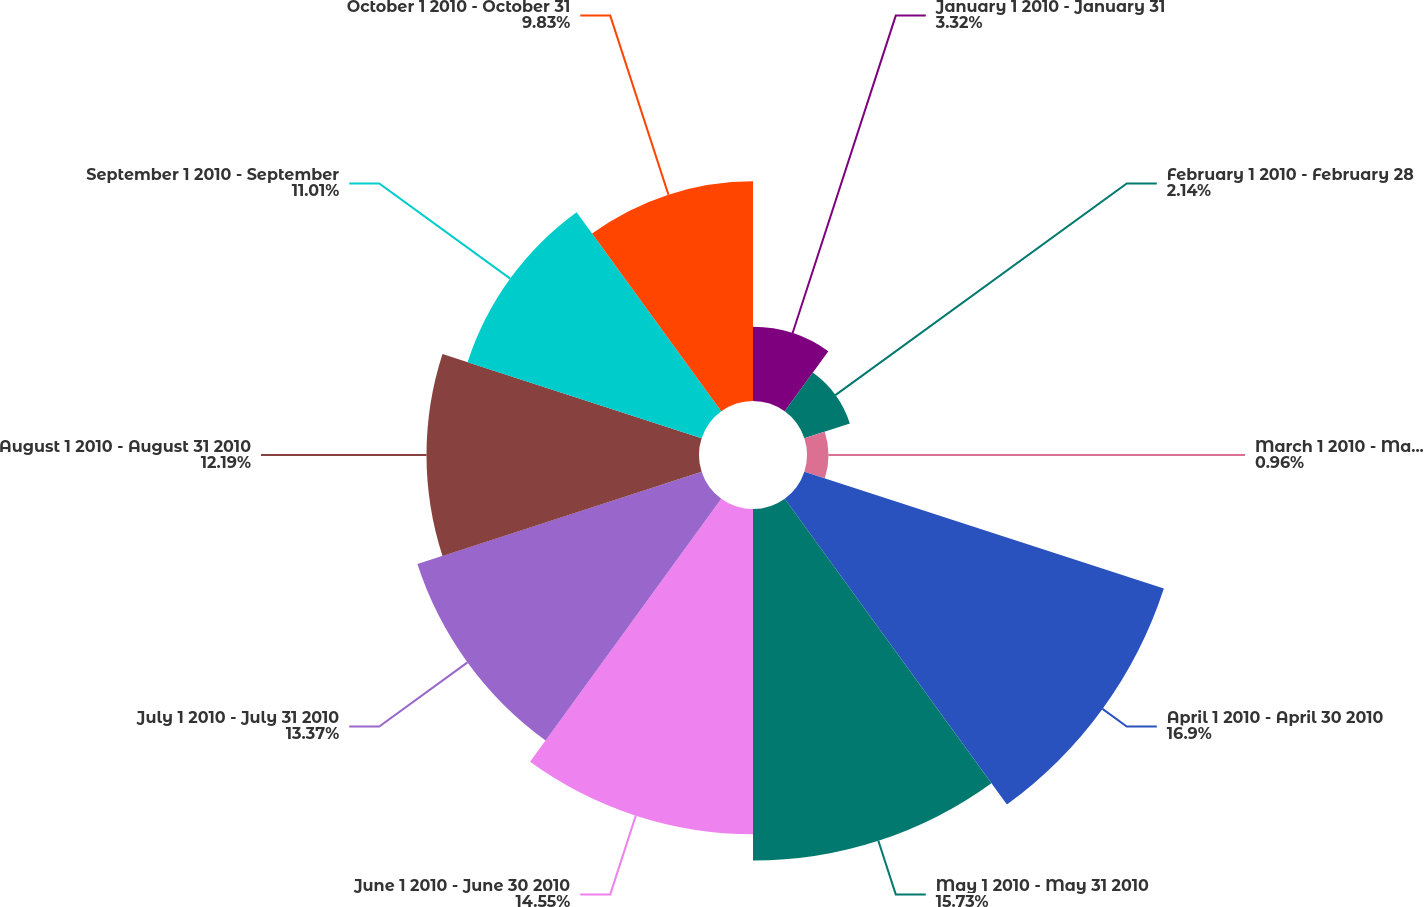Convert chart to OTSL. <chart><loc_0><loc_0><loc_500><loc_500><pie_chart><fcel>January 1 2010 - January 31<fcel>February 1 2010 - February 28<fcel>March 1 2010 - March 31 2010<fcel>April 1 2010 - April 30 2010<fcel>May 1 2010 - May 31 2010<fcel>June 1 2010 - June 30 2010<fcel>July 1 2010 - July 31 2010<fcel>August 1 2010 - August 31 2010<fcel>September 1 2010 - September<fcel>October 1 2010 - October 31<nl><fcel>3.32%<fcel>2.14%<fcel>0.96%<fcel>16.91%<fcel>15.73%<fcel>14.55%<fcel>13.37%<fcel>12.19%<fcel>11.01%<fcel>9.83%<nl></chart> 